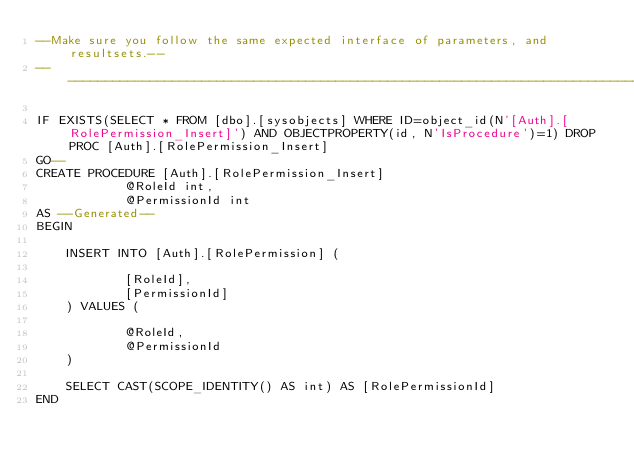<code> <loc_0><loc_0><loc_500><loc_500><_SQL_>--Make sure you follow the same expected interface of parameters, and resultsets.--
-----------------------------------------------------------------------------------

IF EXISTS(SELECT * FROM [dbo].[sysobjects] WHERE ID=object_id(N'[Auth].[RolePermission_Insert]') AND OBJECTPROPERTY(id, N'IsProcedure')=1) DROP PROC [Auth].[RolePermission_Insert]
GO--
CREATE PROCEDURE [Auth].[RolePermission_Insert]
			@RoleId int,
			@PermissionId int
AS --Generated--
BEGIN

	INSERT INTO [Auth].[RolePermission] (

			[RoleId],
			[PermissionId]
	) VALUES (

			@RoleId,
			@PermissionId
	)

	SELECT CAST(SCOPE_IDENTITY() AS int) AS [RolePermissionId]
END</code> 